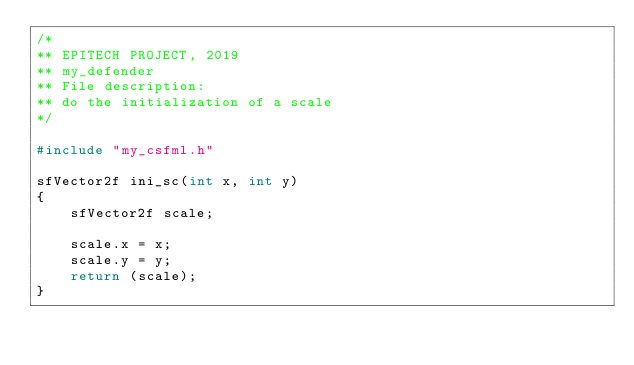Convert code to text. <code><loc_0><loc_0><loc_500><loc_500><_C_>/*
** EPITECH PROJECT, 2019
** my_defender
** File description:
** do the initialization of a scale
*/

#include "my_csfml.h"

sfVector2f ini_sc(int x, int y)
{
    sfVector2f scale;

    scale.x = x;
    scale.y = y;
    return (scale);
}</code> 